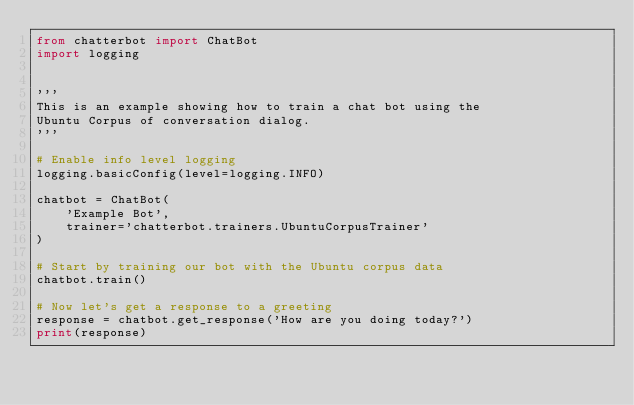Convert code to text. <code><loc_0><loc_0><loc_500><loc_500><_Python_>from chatterbot import ChatBot
import logging


'''
This is an example showing how to train a chat bot using the
Ubuntu Corpus of conversation dialog.
'''

# Enable info level logging
logging.basicConfig(level=logging.INFO)

chatbot = ChatBot(
    'Example Bot',
    trainer='chatterbot.trainers.UbuntuCorpusTrainer'
)

# Start by training our bot with the Ubuntu corpus data
chatbot.train()

# Now let's get a response to a greeting
response = chatbot.get_response('How are you doing today?')
print(response)</code> 